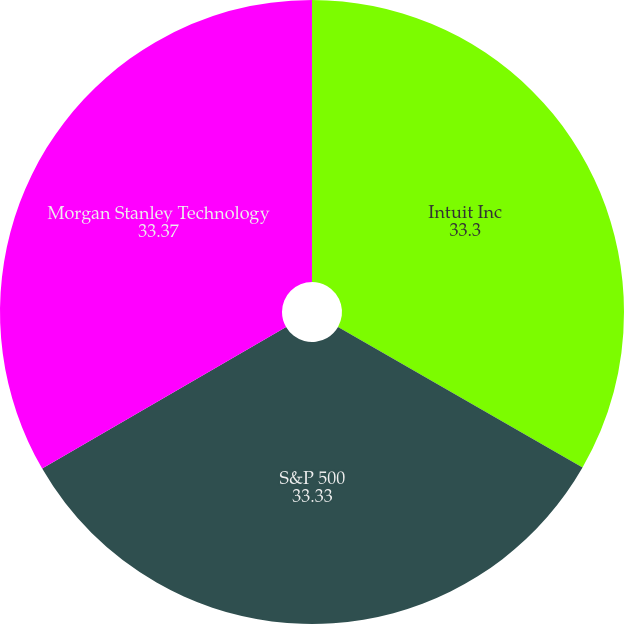<chart> <loc_0><loc_0><loc_500><loc_500><pie_chart><fcel>Intuit Inc<fcel>S&P 500<fcel>Morgan Stanley Technology<nl><fcel>33.3%<fcel>33.33%<fcel>33.37%<nl></chart> 